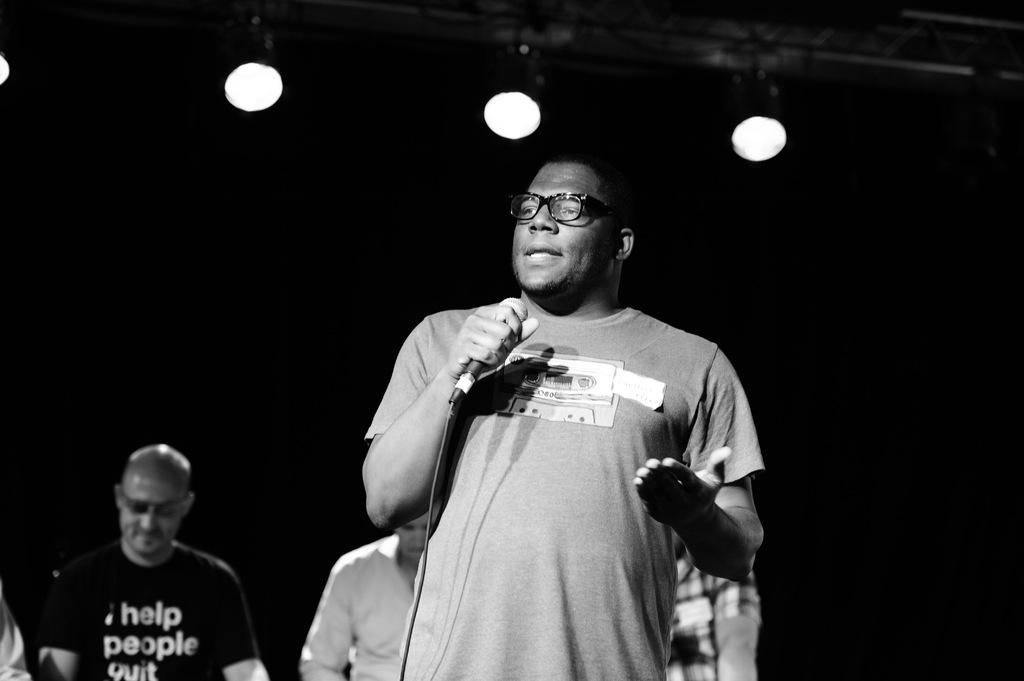Who is the main subject in the picture? There is a man in the picture. What is the man doing with his hand? The man is catching a microphone with his hand. What is the man doing while holding the microphone? The man is talking. Can you describe the audience in the image? There are people sitting behind the man. How is the scene illuminated in the image? There are many lights present in the image. What type of fruit can be seen on the stage in the image? There is no fruit present on the stage in the image. How does the pollution affect the people sitting behind the man in the image? There is no mention of pollution in the image, and therefore its effect on the people cannot be determined. 